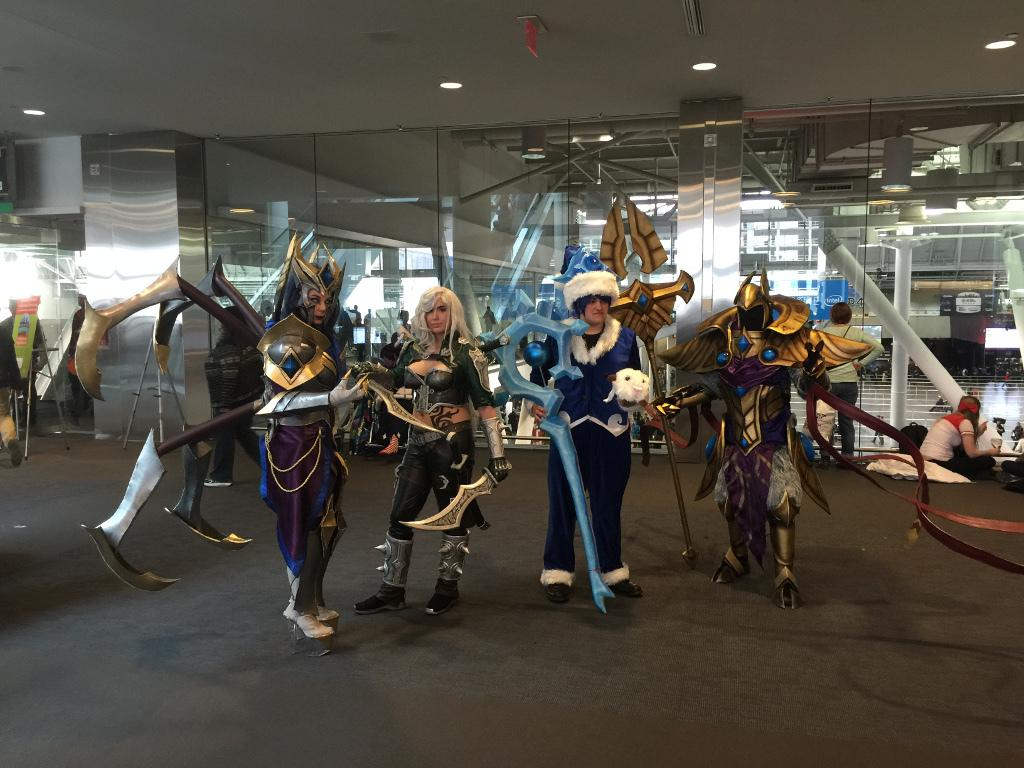How many people are present in the image? There are four people standing in the image. What are the people holding in their hands? The people are holding weapons. What can be seen in the background of the image? There is a glass wall and people in the background of the image. What can be observed in terms of lighting in the image? There are lights visible in the image. Can you describe the bird that is flying in the image? There is no bird present in the image; it only features four people holding weapons and a background with a glass wall and people. 